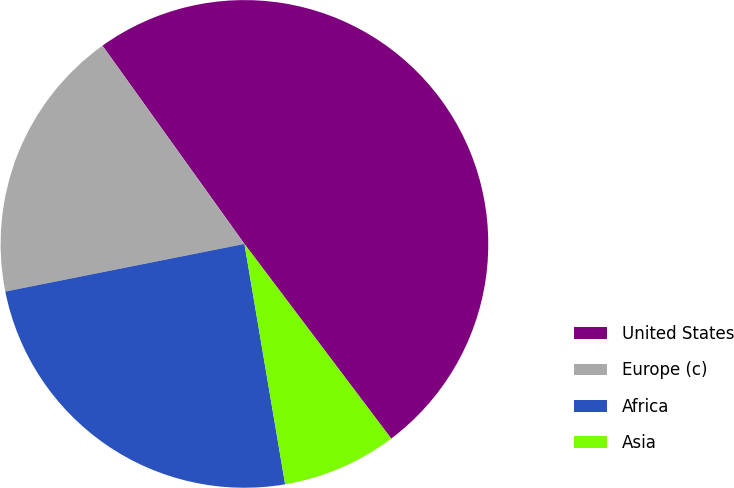Convert chart. <chart><loc_0><loc_0><loc_500><loc_500><pie_chart><fcel>United States<fcel>Europe (c)<fcel>Africa<fcel>Asia<nl><fcel>49.61%<fcel>18.24%<fcel>24.54%<fcel>7.61%<nl></chart> 